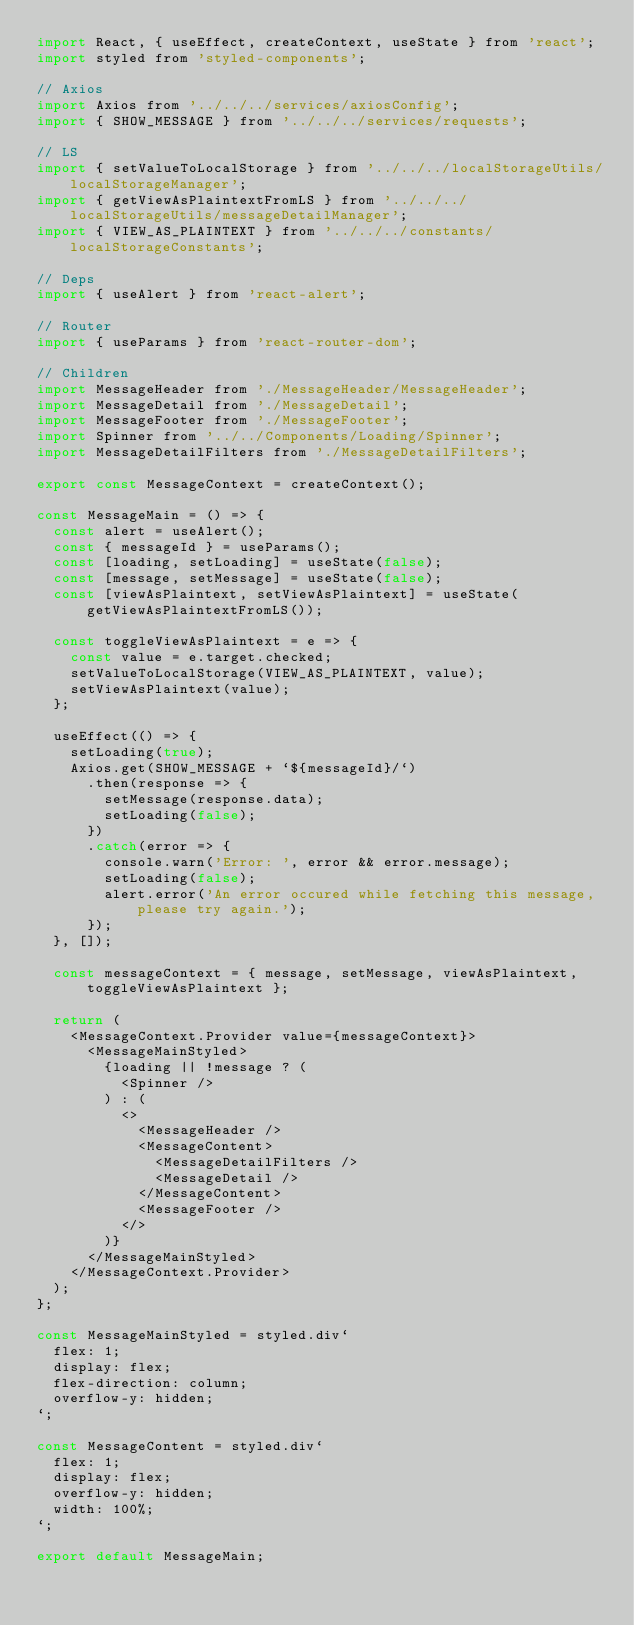Convert code to text. <code><loc_0><loc_0><loc_500><loc_500><_JavaScript_>import React, { useEffect, createContext, useState } from 'react';
import styled from 'styled-components';

// Axios
import Axios from '../../../services/axiosConfig';
import { SHOW_MESSAGE } from '../../../services/requests';

// LS
import { setValueToLocalStorage } from '../../../localStorageUtils/localStorageManager';
import { getViewAsPlaintextFromLS } from '../../../localStorageUtils/messageDetailManager';
import { VIEW_AS_PLAINTEXT } from '../../../constants/localStorageConstants';

// Deps
import { useAlert } from 'react-alert';

// Router
import { useParams } from 'react-router-dom';

// Children
import MessageHeader from './MessageHeader/MessageHeader';
import MessageDetail from './MessageDetail';
import MessageFooter from './MessageFooter';
import Spinner from '../../Components/Loading/Spinner';
import MessageDetailFilters from './MessageDetailFilters';

export const MessageContext = createContext();

const MessageMain = () => {
  const alert = useAlert();
  const { messageId } = useParams();
  const [loading, setLoading] = useState(false);
  const [message, setMessage] = useState(false);
  const [viewAsPlaintext, setViewAsPlaintext] = useState(getViewAsPlaintextFromLS());

  const toggleViewAsPlaintext = e => {
    const value = e.target.checked;
    setValueToLocalStorage(VIEW_AS_PLAINTEXT, value);
    setViewAsPlaintext(value);
  };

  useEffect(() => {
    setLoading(true);
    Axios.get(SHOW_MESSAGE + `${messageId}/`)
      .then(response => {
        setMessage(response.data);
        setLoading(false);
      })
      .catch(error => {
        console.warn('Error: ', error && error.message);
        setLoading(false);
        alert.error('An error occured while fetching this message, please try again.');
      });
  }, []);

  const messageContext = { message, setMessage, viewAsPlaintext, toggleViewAsPlaintext };

  return (
    <MessageContext.Provider value={messageContext}>
      <MessageMainStyled>
        {loading || !message ? (
          <Spinner />
        ) : (
          <>
            <MessageHeader />
            <MessageContent>
              <MessageDetailFilters />
              <MessageDetail />
            </MessageContent>
            <MessageFooter />
          </>
        )}
      </MessageMainStyled>
    </MessageContext.Provider>
  );
};

const MessageMainStyled = styled.div`
  flex: 1;
  display: flex;
  flex-direction: column;
  overflow-y: hidden;
`;

const MessageContent = styled.div`
  flex: 1;
  display: flex;
  overflow-y: hidden;
  width: 100%;
`;

export default MessageMain;
</code> 